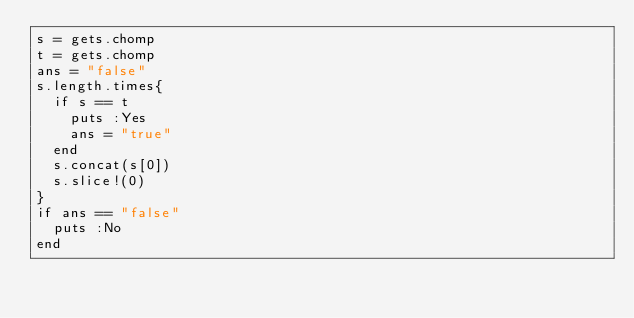Convert code to text. <code><loc_0><loc_0><loc_500><loc_500><_Ruby_>s = gets.chomp
t = gets.chomp
ans = "false"
s.length.times{
  if s == t
    puts :Yes
    ans = "true"
  end
  s.concat(s[0])
  s.slice!(0)
}
if ans == "false"
  puts :No
end</code> 